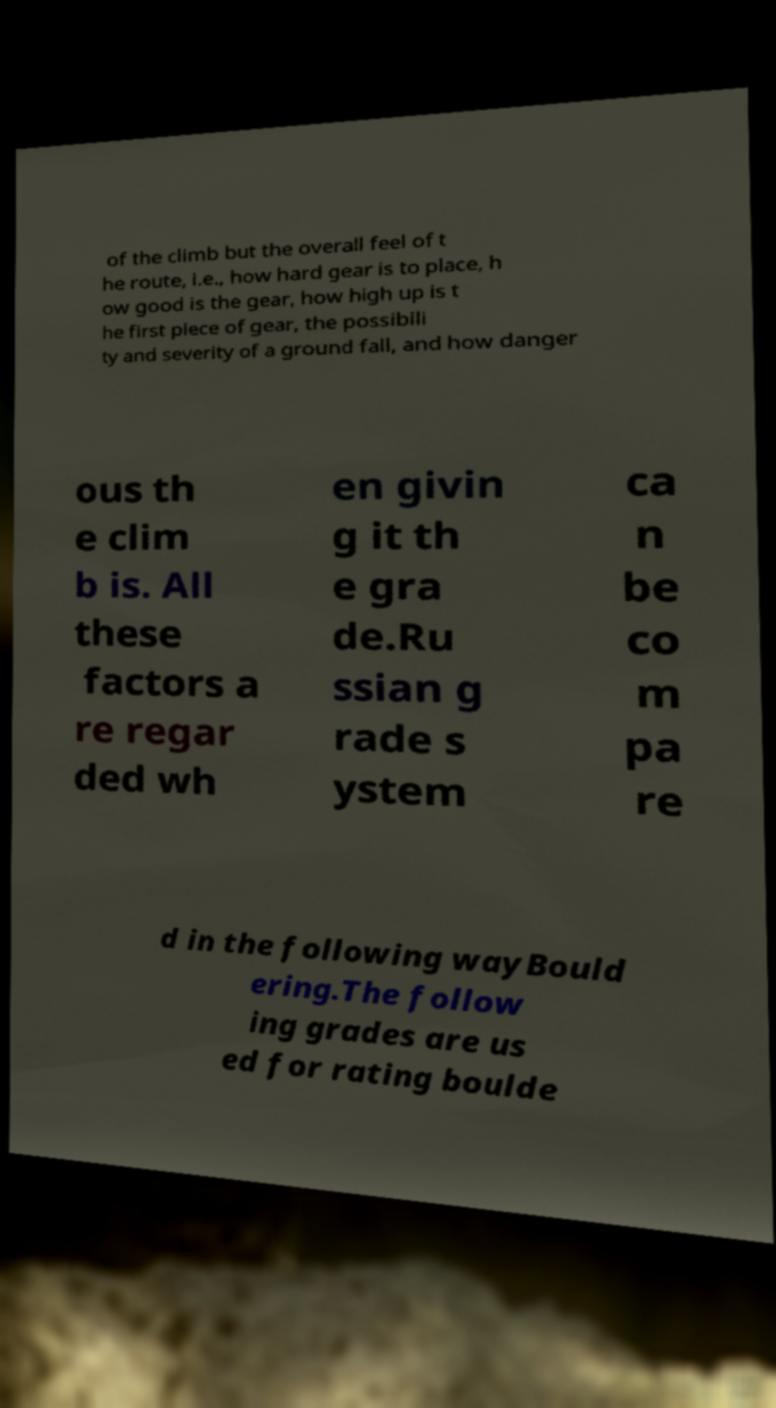I need the written content from this picture converted into text. Can you do that? of the climb but the overall feel of t he route, i.e., how hard gear is to place, h ow good is the gear, how high up is t he first piece of gear, the possibili ty and severity of a ground fall, and how danger ous th e clim b is. All these factors a re regar ded wh en givin g it th e gra de.Ru ssian g rade s ystem ca n be co m pa re d in the following wayBould ering.The follow ing grades are us ed for rating boulde 